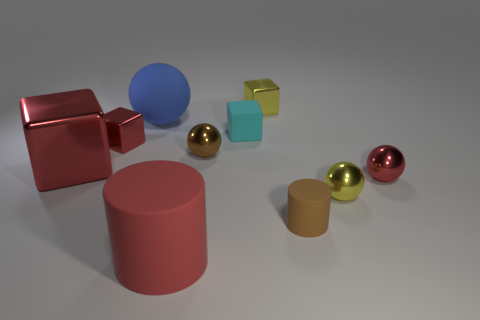Is the number of tiny red shiny balls behind the cyan rubber object less than the number of small yellow cylinders?
Make the answer very short. No. The big red metal object has what shape?
Keep it short and to the point. Cube. How big is the brown ball on the left side of the tiny red ball?
Offer a very short reply. Small. What color is the cylinder that is the same size as the cyan cube?
Provide a short and direct response. Brown. Is there a big object that has the same color as the big sphere?
Your answer should be compact. No. Is the number of tiny things that are behind the yellow ball less than the number of tiny red metallic spheres that are to the left of the cyan rubber cube?
Provide a succinct answer. No. There is a sphere that is in front of the cyan matte object and to the left of the brown rubber object; what material is it?
Give a very brief answer. Metal. There is a blue object; is its shape the same as the small red metallic object left of the blue matte object?
Your response must be concise. No. What number of other objects are there of the same size as the cyan rubber thing?
Provide a succinct answer. 6. Is the number of big red things greater than the number of yellow metal blocks?
Offer a terse response. Yes. 